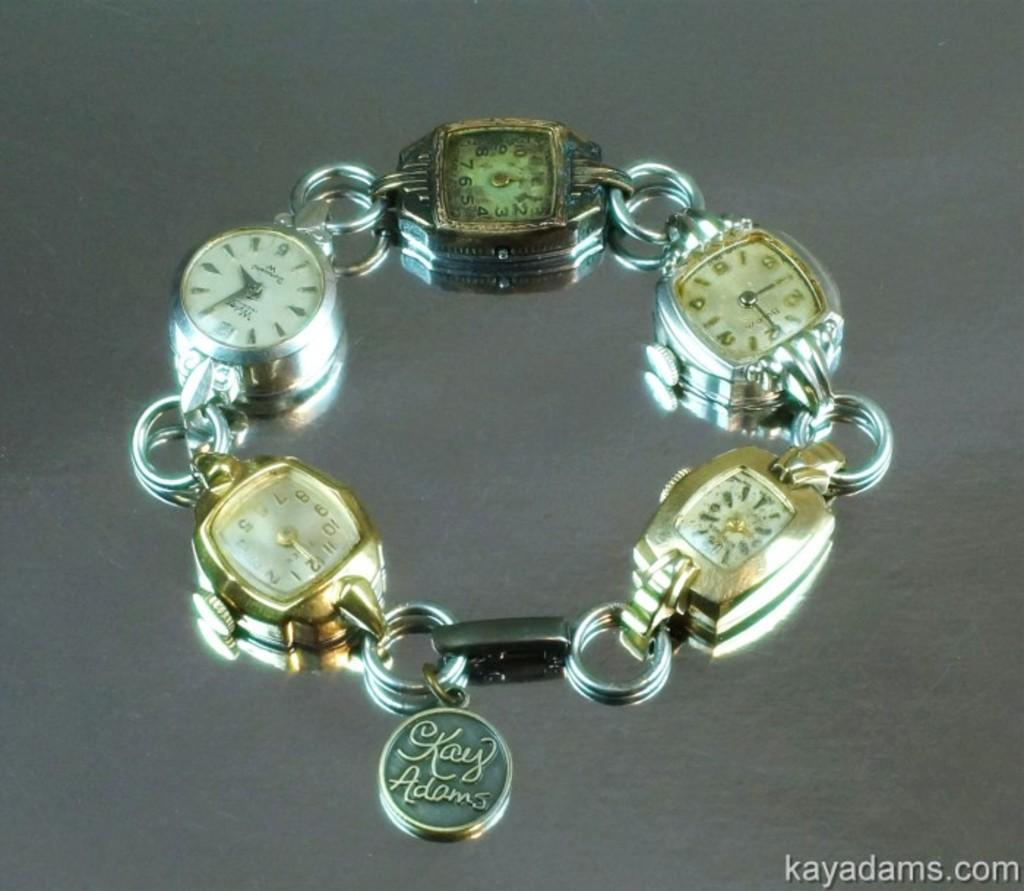<image>
Share a concise interpretation of the image provided. A charm bracelet of watch faces and a charm that has the word key engraved on it 